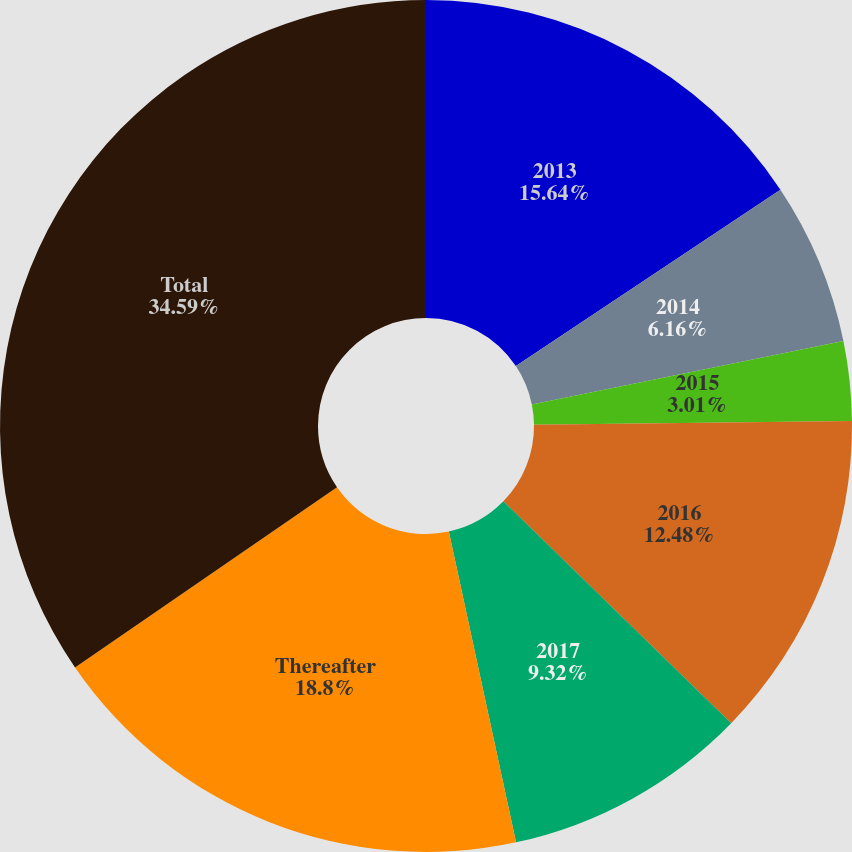Convert chart to OTSL. <chart><loc_0><loc_0><loc_500><loc_500><pie_chart><fcel>2013<fcel>2014<fcel>2015<fcel>2016<fcel>2017<fcel>Thereafter<fcel>Total<nl><fcel>15.64%<fcel>6.16%<fcel>3.01%<fcel>12.48%<fcel>9.32%<fcel>18.8%<fcel>34.59%<nl></chart> 